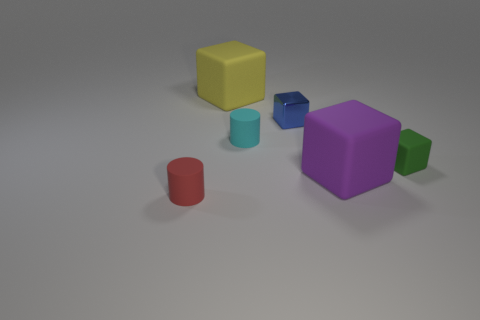Add 3 cylinders. How many objects exist? 9 Subtract all blocks. How many objects are left? 2 Add 5 tiny red cylinders. How many tiny red cylinders are left? 6 Add 2 small green shiny cylinders. How many small green shiny cylinders exist? 2 Subtract 0 red cubes. How many objects are left? 6 Subtract all green blocks. Subtract all green metallic things. How many objects are left? 5 